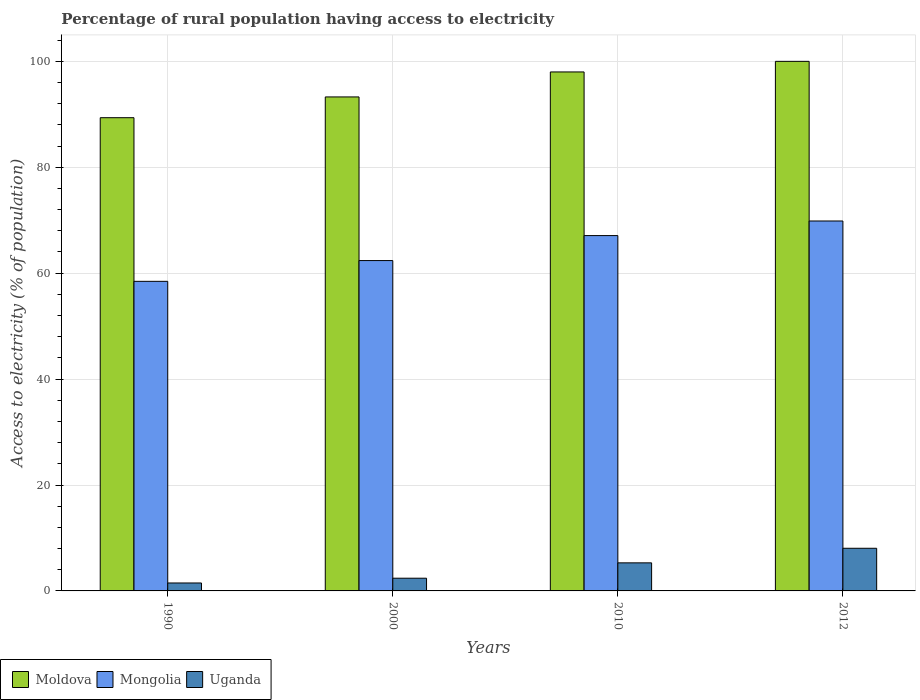How many groups of bars are there?
Your response must be concise. 4. Are the number of bars per tick equal to the number of legend labels?
Keep it short and to the point. Yes. How many bars are there on the 4th tick from the left?
Offer a very short reply. 3. How many bars are there on the 1st tick from the right?
Provide a short and direct response. 3. What is the label of the 2nd group of bars from the left?
Offer a very short reply. 2000. In how many cases, is the number of bars for a given year not equal to the number of legend labels?
Your response must be concise. 0. What is the percentage of rural population having access to electricity in Mongolia in 2010?
Offer a very short reply. 67.1. Across all years, what is the minimum percentage of rural population having access to electricity in Uganda?
Offer a terse response. 1.5. In which year was the percentage of rural population having access to electricity in Moldova minimum?
Offer a terse response. 1990. What is the total percentage of rural population having access to electricity in Moldova in the graph?
Your answer should be very brief. 380.64. What is the difference between the percentage of rural population having access to electricity in Mongolia in 1990 and that in 2012?
Your answer should be compact. -11.39. What is the difference between the percentage of rural population having access to electricity in Mongolia in 2012 and the percentage of rural population having access to electricity in Moldova in 1990?
Your answer should be very brief. -19.51. What is the average percentage of rural population having access to electricity in Uganda per year?
Provide a short and direct response. 4.31. In the year 2010, what is the difference between the percentage of rural population having access to electricity in Uganda and percentage of rural population having access to electricity in Moldova?
Give a very brief answer. -92.7. In how many years, is the percentage of rural population having access to electricity in Uganda greater than 36 %?
Give a very brief answer. 0. What is the ratio of the percentage of rural population having access to electricity in Uganda in 2000 to that in 2010?
Keep it short and to the point. 0.45. Is the difference between the percentage of rural population having access to electricity in Uganda in 2010 and 2012 greater than the difference between the percentage of rural population having access to electricity in Moldova in 2010 and 2012?
Give a very brief answer. No. What is the difference between the highest and the second highest percentage of rural population having access to electricity in Moldova?
Your answer should be very brief. 2. What is the difference between the highest and the lowest percentage of rural population having access to electricity in Mongolia?
Your response must be concise. 11.39. In how many years, is the percentage of rural population having access to electricity in Moldova greater than the average percentage of rural population having access to electricity in Moldova taken over all years?
Your answer should be compact. 2. What does the 2nd bar from the left in 1990 represents?
Provide a short and direct response. Mongolia. What does the 2nd bar from the right in 2010 represents?
Keep it short and to the point. Mongolia. Is it the case that in every year, the sum of the percentage of rural population having access to electricity in Mongolia and percentage of rural population having access to electricity in Moldova is greater than the percentage of rural population having access to electricity in Uganda?
Provide a succinct answer. Yes. How many bars are there?
Keep it short and to the point. 12. What is the difference between two consecutive major ticks on the Y-axis?
Provide a short and direct response. 20. Are the values on the major ticks of Y-axis written in scientific E-notation?
Your response must be concise. No. Where does the legend appear in the graph?
Make the answer very short. Bottom left. How many legend labels are there?
Offer a terse response. 3. What is the title of the graph?
Your answer should be very brief. Percentage of rural population having access to electricity. What is the label or title of the Y-axis?
Offer a very short reply. Access to electricity (% of population). What is the Access to electricity (% of population) of Moldova in 1990?
Provide a succinct answer. 89.36. What is the Access to electricity (% of population) in Mongolia in 1990?
Give a very brief answer. 58.46. What is the Access to electricity (% of population) in Moldova in 2000?
Offer a terse response. 93.28. What is the Access to electricity (% of population) of Mongolia in 2000?
Give a very brief answer. 62.38. What is the Access to electricity (% of population) in Moldova in 2010?
Your answer should be very brief. 98. What is the Access to electricity (% of population) of Mongolia in 2010?
Give a very brief answer. 67.1. What is the Access to electricity (% of population) in Moldova in 2012?
Provide a succinct answer. 100. What is the Access to electricity (% of population) of Mongolia in 2012?
Offer a very short reply. 69.85. What is the Access to electricity (% of population) of Uganda in 2012?
Offer a terse response. 8.05. Across all years, what is the maximum Access to electricity (% of population) in Moldova?
Your response must be concise. 100. Across all years, what is the maximum Access to electricity (% of population) in Mongolia?
Provide a short and direct response. 69.85. Across all years, what is the maximum Access to electricity (% of population) of Uganda?
Your answer should be very brief. 8.05. Across all years, what is the minimum Access to electricity (% of population) in Moldova?
Your response must be concise. 89.36. Across all years, what is the minimum Access to electricity (% of population) of Mongolia?
Offer a terse response. 58.46. What is the total Access to electricity (% of population) in Moldova in the graph?
Provide a succinct answer. 380.64. What is the total Access to electricity (% of population) of Mongolia in the graph?
Provide a succinct answer. 257.8. What is the total Access to electricity (% of population) in Uganda in the graph?
Make the answer very short. 17.25. What is the difference between the Access to electricity (% of population) of Moldova in 1990 and that in 2000?
Provide a succinct answer. -3.92. What is the difference between the Access to electricity (% of population) of Mongolia in 1990 and that in 2000?
Ensure brevity in your answer.  -3.92. What is the difference between the Access to electricity (% of population) in Uganda in 1990 and that in 2000?
Offer a very short reply. -0.9. What is the difference between the Access to electricity (% of population) of Moldova in 1990 and that in 2010?
Keep it short and to the point. -8.64. What is the difference between the Access to electricity (% of population) of Mongolia in 1990 and that in 2010?
Your answer should be very brief. -8.64. What is the difference between the Access to electricity (% of population) in Uganda in 1990 and that in 2010?
Your answer should be compact. -3.8. What is the difference between the Access to electricity (% of population) in Moldova in 1990 and that in 2012?
Your answer should be very brief. -10.64. What is the difference between the Access to electricity (% of population) of Mongolia in 1990 and that in 2012?
Your response must be concise. -11.39. What is the difference between the Access to electricity (% of population) in Uganda in 1990 and that in 2012?
Give a very brief answer. -6.55. What is the difference between the Access to electricity (% of population) in Moldova in 2000 and that in 2010?
Ensure brevity in your answer.  -4.72. What is the difference between the Access to electricity (% of population) in Mongolia in 2000 and that in 2010?
Keep it short and to the point. -4.72. What is the difference between the Access to electricity (% of population) of Moldova in 2000 and that in 2012?
Provide a short and direct response. -6.72. What is the difference between the Access to electricity (% of population) in Mongolia in 2000 and that in 2012?
Provide a succinct answer. -7.47. What is the difference between the Access to electricity (% of population) in Uganda in 2000 and that in 2012?
Your answer should be compact. -5.65. What is the difference between the Access to electricity (% of population) in Mongolia in 2010 and that in 2012?
Make the answer very short. -2.75. What is the difference between the Access to electricity (% of population) in Uganda in 2010 and that in 2012?
Provide a short and direct response. -2.75. What is the difference between the Access to electricity (% of population) of Moldova in 1990 and the Access to electricity (% of population) of Mongolia in 2000?
Give a very brief answer. 26.98. What is the difference between the Access to electricity (% of population) in Moldova in 1990 and the Access to electricity (% of population) in Uganda in 2000?
Ensure brevity in your answer.  86.96. What is the difference between the Access to electricity (% of population) in Mongolia in 1990 and the Access to electricity (% of population) in Uganda in 2000?
Provide a short and direct response. 56.06. What is the difference between the Access to electricity (% of population) in Moldova in 1990 and the Access to electricity (% of population) in Mongolia in 2010?
Offer a terse response. 22.26. What is the difference between the Access to electricity (% of population) of Moldova in 1990 and the Access to electricity (% of population) of Uganda in 2010?
Offer a very short reply. 84.06. What is the difference between the Access to electricity (% of population) in Mongolia in 1990 and the Access to electricity (% of population) in Uganda in 2010?
Offer a terse response. 53.16. What is the difference between the Access to electricity (% of population) in Moldova in 1990 and the Access to electricity (% of population) in Mongolia in 2012?
Keep it short and to the point. 19.51. What is the difference between the Access to electricity (% of population) of Moldova in 1990 and the Access to electricity (% of population) of Uganda in 2012?
Provide a succinct answer. 81.31. What is the difference between the Access to electricity (% of population) of Mongolia in 1990 and the Access to electricity (% of population) of Uganda in 2012?
Your answer should be compact. 50.41. What is the difference between the Access to electricity (% of population) of Moldova in 2000 and the Access to electricity (% of population) of Mongolia in 2010?
Provide a short and direct response. 26.18. What is the difference between the Access to electricity (% of population) of Moldova in 2000 and the Access to electricity (% of population) of Uganda in 2010?
Make the answer very short. 87.98. What is the difference between the Access to electricity (% of population) in Mongolia in 2000 and the Access to electricity (% of population) in Uganda in 2010?
Keep it short and to the point. 57.08. What is the difference between the Access to electricity (% of population) of Moldova in 2000 and the Access to electricity (% of population) of Mongolia in 2012?
Your answer should be very brief. 23.43. What is the difference between the Access to electricity (% of population) of Moldova in 2000 and the Access to electricity (% of population) of Uganda in 2012?
Give a very brief answer. 85.23. What is the difference between the Access to electricity (% of population) of Mongolia in 2000 and the Access to electricity (% of population) of Uganda in 2012?
Your answer should be very brief. 54.33. What is the difference between the Access to electricity (% of population) of Moldova in 2010 and the Access to electricity (% of population) of Mongolia in 2012?
Ensure brevity in your answer.  28.15. What is the difference between the Access to electricity (% of population) in Moldova in 2010 and the Access to electricity (% of population) in Uganda in 2012?
Give a very brief answer. 89.95. What is the difference between the Access to electricity (% of population) of Mongolia in 2010 and the Access to electricity (% of population) of Uganda in 2012?
Offer a very short reply. 59.05. What is the average Access to electricity (% of population) in Moldova per year?
Provide a succinct answer. 95.16. What is the average Access to electricity (% of population) in Mongolia per year?
Make the answer very short. 64.45. What is the average Access to electricity (% of population) in Uganda per year?
Ensure brevity in your answer.  4.31. In the year 1990, what is the difference between the Access to electricity (% of population) of Moldova and Access to electricity (% of population) of Mongolia?
Make the answer very short. 30.9. In the year 1990, what is the difference between the Access to electricity (% of population) of Moldova and Access to electricity (% of population) of Uganda?
Provide a succinct answer. 87.86. In the year 1990, what is the difference between the Access to electricity (% of population) in Mongolia and Access to electricity (% of population) in Uganda?
Make the answer very short. 56.96. In the year 2000, what is the difference between the Access to electricity (% of population) of Moldova and Access to electricity (% of population) of Mongolia?
Provide a succinct answer. 30.9. In the year 2000, what is the difference between the Access to electricity (% of population) of Moldova and Access to electricity (% of population) of Uganda?
Provide a short and direct response. 90.88. In the year 2000, what is the difference between the Access to electricity (% of population) of Mongolia and Access to electricity (% of population) of Uganda?
Your response must be concise. 59.98. In the year 2010, what is the difference between the Access to electricity (% of population) in Moldova and Access to electricity (% of population) in Mongolia?
Ensure brevity in your answer.  30.9. In the year 2010, what is the difference between the Access to electricity (% of population) in Moldova and Access to electricity (% of population) in Uganda?
Provide a short and direct response. 92.7. In the year 2010, what is the difference between the Access to electricity (% of population) in Mongolia and Access to electricity (% of population) in Uganda?
Provide a short and direct response. 61.8. In the year 2012, what is the difference between the Access to electricity (% of population) in Moldova and Access to electricity (% of population) in Mongolia?
Offer a terse response. 30.15. In the year 2012, what is the difference between the Access to electricity (% of population) of Moldova and Access to electricity (% of population) of Uganda?
Keep it short and to the point. 91.95. In the year 2012, what is the difference between the Access to electricity (% of population) of Mongolia and Access to electricity (% of population) of Uganda?
Keep it short and to the point. 61.8. What is the ratio of the Access to electricity (% of population) of Moldova in 1990 to that in 2000?
Your response must be concise. 0.96. What is the ratio of the Access to electricity (% of population) of Mongolia in 1990 to that in 2000?
Provide a succinct answer. 0.94. What is the ratio of the Access to electricity (% of population) of Uganda in 1990 to that in 2000?
Provide a succinct answer. 0.62. What is the ratio of the Access to electricity (% of population) in Moldova in 1990 to that in 2010?
Keep it short and to the point. 0.91. What is the ratio of the Access to electricity (% of population) of Mongolia in 1990 to that in 2010?
Offer a very short reply. 0.87. What is the ratio of the Access to electricity (% of population) of Uganda in 1990 to that in 2010?
Give a very brief answer. 0.28. What is the ratio of the Access to electricity (% of population) of Moldova in 1990 to that in 2012?
Your answer should be compact. 0.89. What is the ratio of the Access to electricity (% of population) of Mongolia in 1990 to that in 2012?
Ensure brevity in your answer.  0.84. What is the ratio of the Access to electricity (% of population) of Uganda in 1990 to that in 2012?
Your response must be concise. 0.19. What is the ratio of the Access to electricity (% of population) in Moldova in 2000 to that in 2010?
Provide a succinct answer. 0.95. What is the ratio of the Access to electricity (% of population) in Mongolia in 2000 to that in 2010?
Your response must be concise. 0.93. What is the ratio of the Access to electricity (% of population) of Uganda in 2000 to that in 2010?
Give a very brief answer. 0.45. What is the ratio of the Access to electricity (% of population) of Moldova in 2000 to that in 2012?
Your answer should be compact. 0.93. What is the ratio of the Access to electricity (% of population) of Mongolia in 2000 to that in 2012?
Provide a succinct answer. 0.89. What is the ratio of the Access to electricity (% of population) of Uganda in 2000 to that in 2012?
Provide a short and direct response. 0.3. What is the ratio of the Access to electricity (% of population) of Mongolia in 2010 to that in 2012?
Your answer should be compact. 0.96. What is the ratio of the Access to electricity (% of population) in Uganda in 2010 to that in 2012?
Ensure brevity in your answer.  0.66. What is the difference between the highest and the second highest Access to electricity (% of population) of Mongolia?
Make the answer very short. 2.75. What is the difference between the highest and the second highest Access to electricity (% of population) in Uganda?
Ensure brevity in your answer.  2.75. What is the difference between the highest and the lowest Access to electricity (% of population) of Moldova?
Give a very brief answer. 10.64. What is the difference between the highest and the lowest Access to electricity (% of population) in Mongolia?
Your response must be concise. 11.39. What is the difference between the highest and the lowest Access to electricity (% of population) in Uganda?
Offer a very short reply. 6.55. 